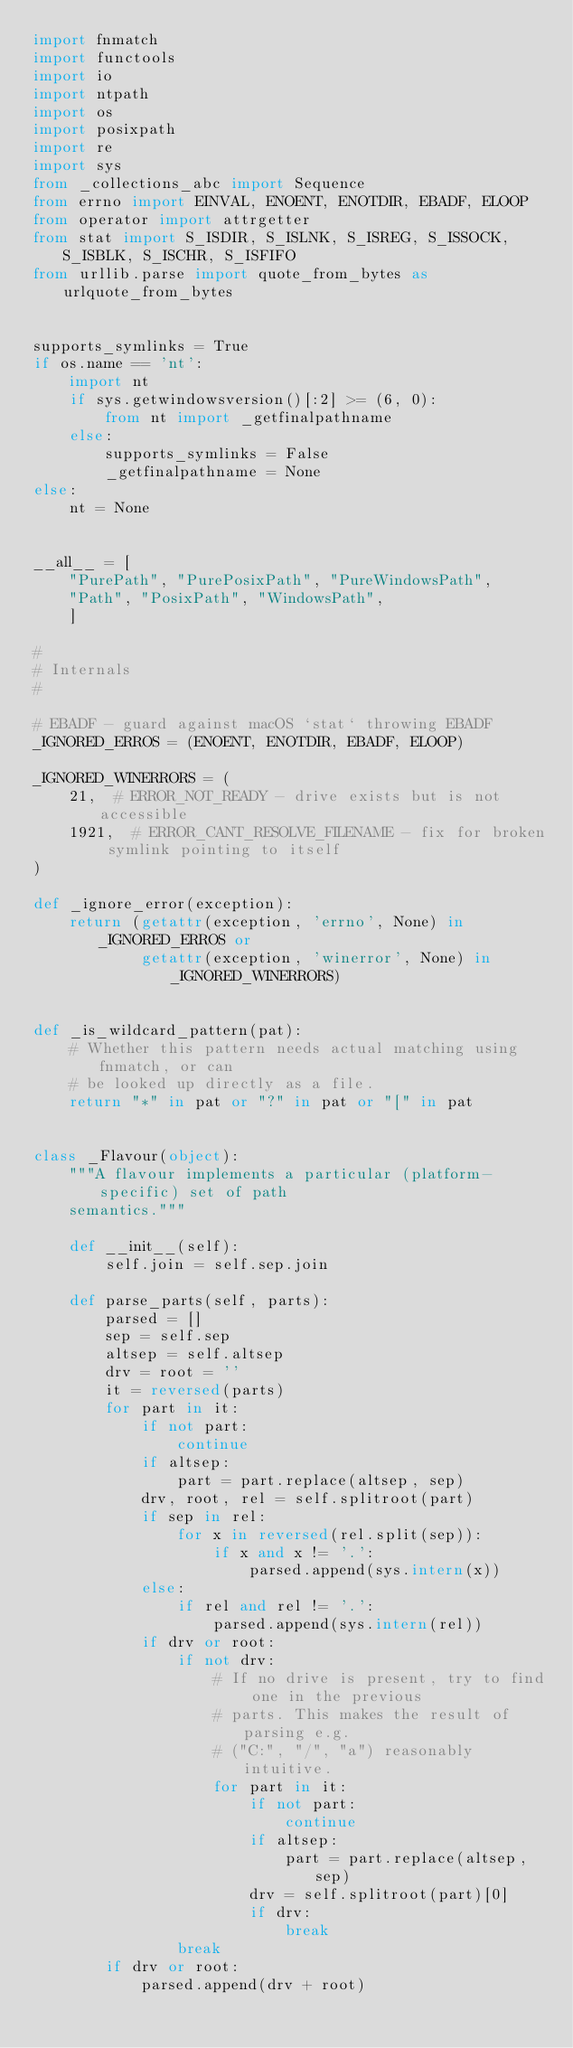<code> <loc_0><loc_0><loc_500><loc_500><_Python_>import fnmatch
import functools
import io
import ntpath
import os
import posixpath
import re
import sys
from _collections_abc import Sequence
from errno import EINVAL, ENOENT, ENOTDIR, EBADF, ELOOP
from operator import attrgetter
from stat import S_ISDIR, S_ISLNK, S_ISREG, S_ISSOCK, S_ISBLK, S_ISCHR, S_ISFIFO
from urllib.parse import quote_from_bytes as urlquote_from_bytes


supports_symlinks = True
if os.name == 'nt':
    import nt
    if sys.getwindowsversion()[:2] >= (6, 0):
        from nt import _getfinalpathname
    else:
        supports_symlinks = False
        _getfinalpathname = None
else:
    nt = None


__all__ = [
    "PurePath", "PurePosixPath", "PureWindowsPath",
    "Path", "PosixPath", "WindowsPath",
    ]

#
# Internals
#

# EBADF - guard against macOS `stat` throwing EBADF
_IGNORED_ERROS = (ENOENT, ENOTDIR, EBADF, ELOOP)

_IGNORED_WINERRORS = (
    21,  # ERROR_NOT_READY - drive exists but is not accessible
    1921,  # ERROR_CANT_RESOLVE_FILENAME - fix for broken symlink pointing to itself
)

def _ignore_error(exception):
    return (getattr(exception, 'errno', None) in _IGNORED_ERROS or
            getattr(exception, 'winerror', None) in _IGNORED_WINERRORS)


def _is_wildcard_pattern(pat):
    # Whether this pattern needs actual matching using fnmatch, or can
    # be looked up directly as a file.
    return "*" in pat or "?" in pat or "[" in pat


class _Flavour(object):
    """A flavour implements a particular (platform-specific) set of path
    semantics."""

    def __init__(self):
        self.join = self.sep.join

    def parse_parts(self, parts):
        parsed = []
        sep = self.sep
        altsep = self.altsep
        drv = root = ''
        it = reversed(parts)
        for part in it:
            if not part:
                continue
            if altsep:
                part = part.replace(altsep, sep)
            drv, root, rel = self.splitroot(part)
            if sep in rel:
                for x in reversed(rel.split(sep)):
                    if x and x != '.':
                        parsed.append(sys.intern(x))
            else:
                if rel and rel != '.':
                    parsed.append(sys.intern(rel))
            if drv or root:
                if not drv:
                    # If no drive is present, try to find one in the previous
                    # parts. This makes the result of parsing e.g.
                    # ("C:", "/", "a") reasonably intuitive.
                    for part in it:
                        if not part:
                            continue
                        if altsep:
                            part = part.replace(altsep, sep)
                        drv = self.splitroot(part)[0]
                        if drv:
                            break
                break
        if drv or root:
            parsed.append(drv + root)</code> 